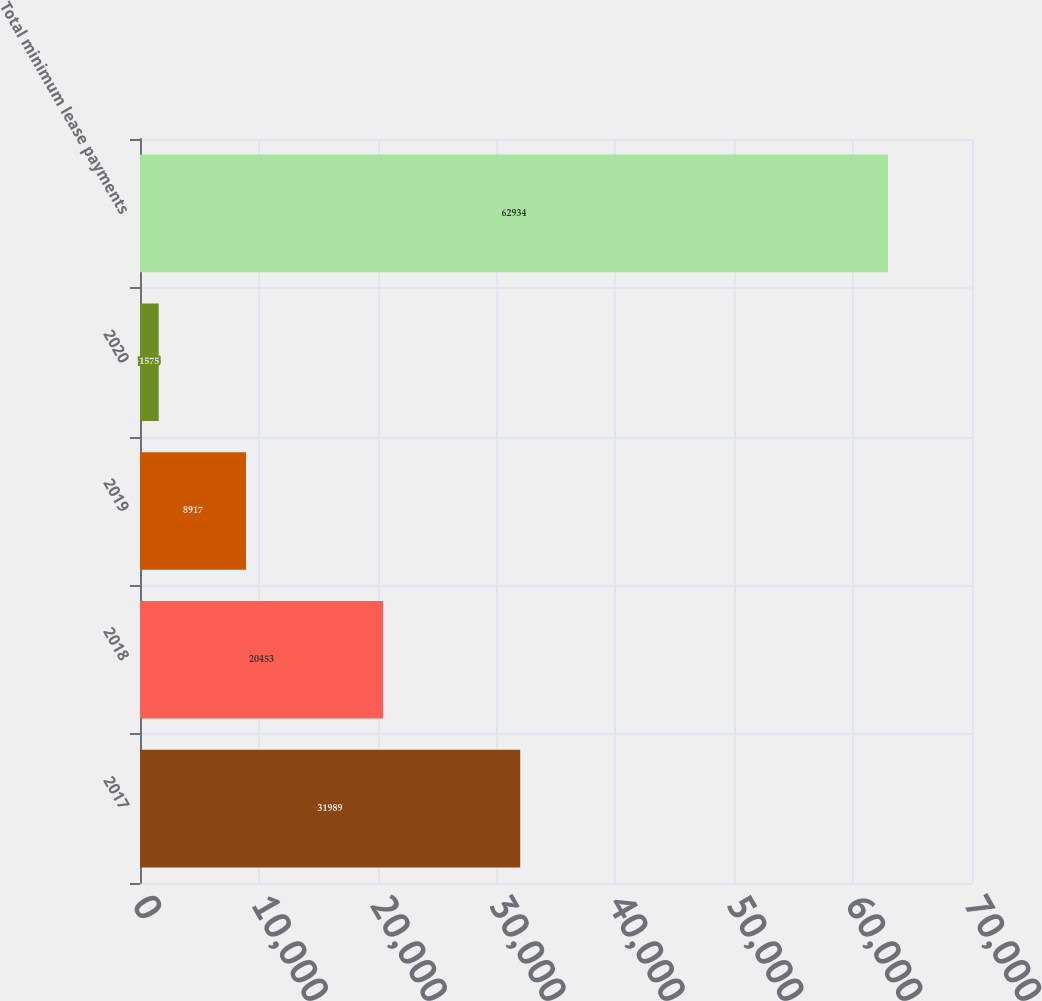Convert chart. <chart><loc_0><loc_0><loc_500><loc_500><bar_chart><fcel>2017<fcel>2018<fcel>2019<fcel>2020<fcel>Total minimum lease payments<nl><fcel>31989<fcel>20453<fcel>8917<fcel>1575<fcel>62934<nl></chart> 